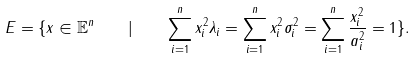Convert formula to latex. <formula><loc_0><loc_0><loc_500><loc_500>E = \{ x \in \mathbb { E } ^ { n } \quad | \quad \sum _ { i = 1 } ^ { n } x _ { i } ^ { 2 } \lambda _ { i } = \sum _ { i = 1 } ^ { n } x _ { i } ^ { 2 } \sigma _ { i } ^ { 2 } = \sum _ { i = 1 } ^ { n } \frac { x _ { i } ^ { 2 } } { a _ { i } ^ { 2 } } = 1 \} .</formula> 